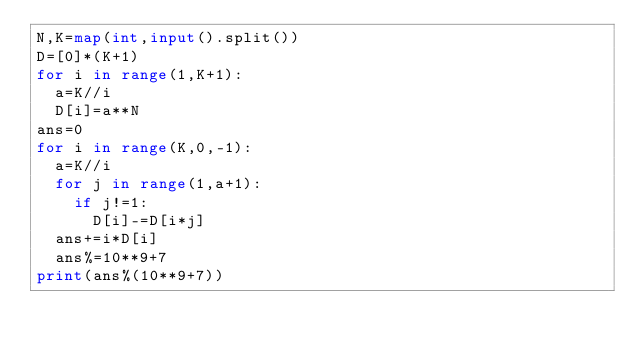Convert code to text. <code><loc_0><loc_0><loc_500><loc_500><_Python_>N,K=map(int,input().split())
D=[0]*(K+1)
for i in range(1,K+1):
  a=K//i
  D[i]=a**N
ans=0
for i in range(K,0,-1):
  a=K//i
  for j in range(1,a+1):
    if j!=1:
      D[i]-=D[i*j]
  ans+=i*D[i]
  ans%=10**9+7
print(ans%(10**9+7))  </code> 